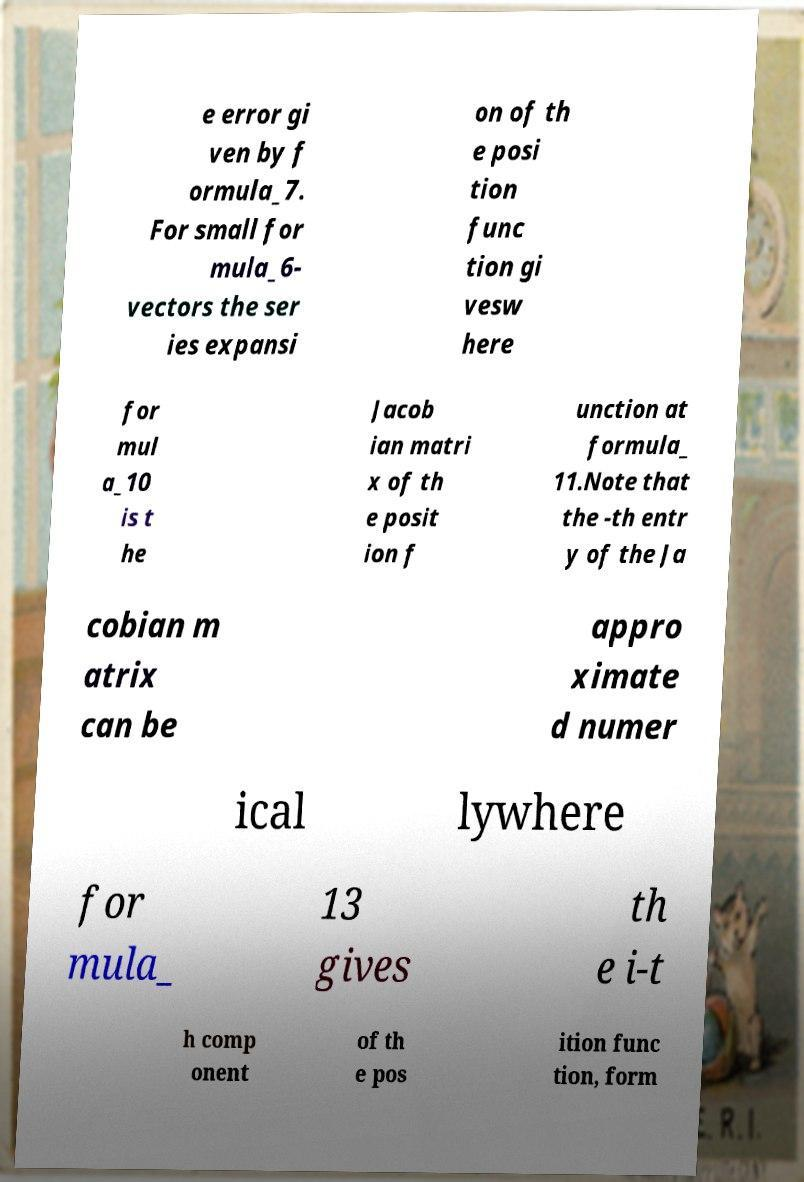For documentation purposes, I need the text within this image transcribed. Could you provide that? e error gi ven by f ormula_7. For small for mula_6- vectors the ser ies expansi on of th e posi tion func tion gi vesw here for mul a_10 is t he Jacob ian matri x of th e posit ion f unction at formula_ 11.Note that the -th entr y of the Ja cobian m atrix can be appro ximate d numer ical lywhere for mula_ 13 gives th e i-t h comp onent of th e pos ition func tion, form 